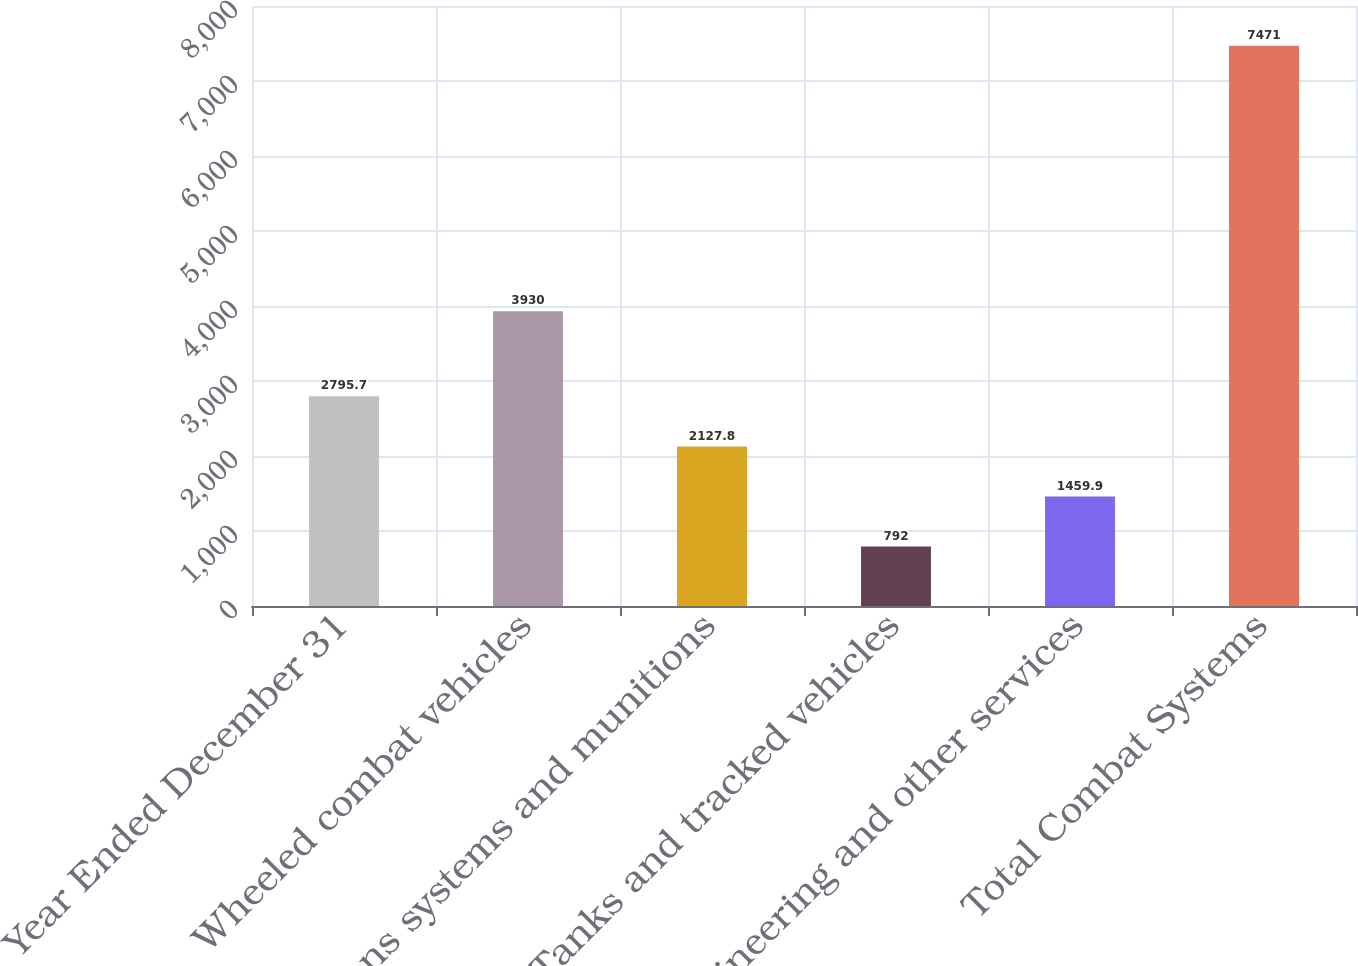<chart> <loc_0><loc_0><loc_500><loc_500><bar_chart><fcel>Year Ended December 31<fcel>Wheeled combat vehicles<fcel>Weapons systems and munitions<fcel>Tanks and tracked vehicles<fcel>Engineering and other services<fcel>Total Combat Systems<nl><fcel>2795.7<fcel>3930<fcel>2127.8<fcel>792<fcel>1459.9<fcel>7471<nl></chart> 